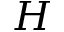Convert formula to latex. <formula><loc_0><loc_0><loc_500><loc_500>{ H }</formula> 